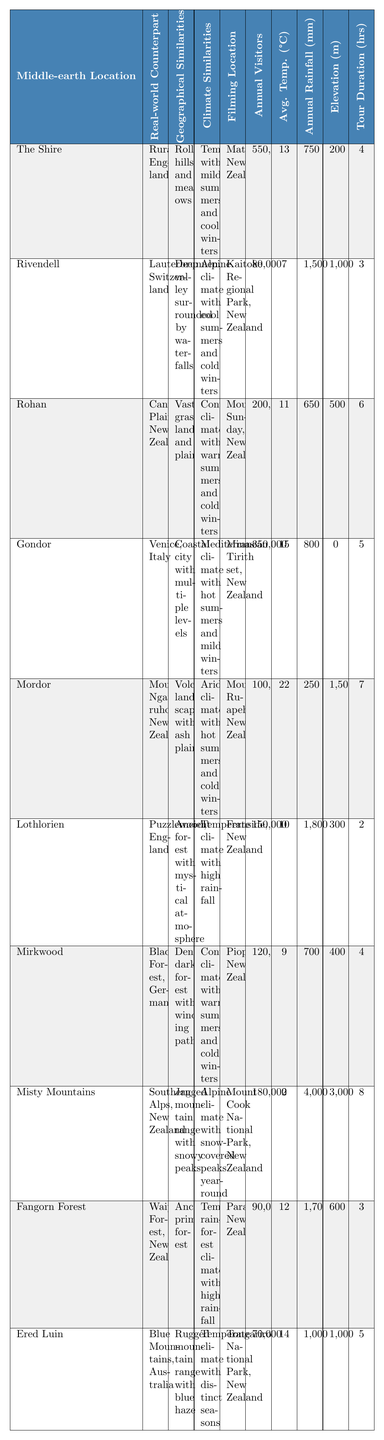What is the real-world counterpart of The Shire? Referring to the table, The Shire corresponds to Rural England.
Answer: Rural England Which Middle-earth location has the highest average temperature? By examining the average temperatures provided, Mordor has the highest average temperature at 22°C.
Answer: 22°C How many annual visitors does Rivendell have? According to the data in the table, Rivendell has 80,000 annual visitors.
Answer: 80,000 Is the climate of Gondor Mediterranean? The table indicates that Gondor has a Mediterranean climate, so the answer is yes.
Answer: Yes Which location has the lowest elevation? By comparing the elevation values, Gondor has an elevation of 0 meters, making it the lowest.
Answer: 0 meters What is the average annual rainfall of Lothlorien? Referring to the rainfall data, Lothlorien receives 1,800 mm of annual rainfall.
Answer: 1,800 mm Calculate the total annual visitors for the locations in New Zealand (The Shire, Rohan, Gondor, Mordor, Lothlorien, Mirkwood, Misty Mountains, Fangorn Forest, Ered Luin). The total is calculated as 550,000 + 200,000 + 350,000 + 100,000 + 150,000 + 120,000 + 180,000 + 90,000 + 70,000 = 1,810,000 visitors.
Answer: 1,810,000 Which location has both high rainfall and high elevation? Referring to the table, Misty Mountains has 4,000 mm of annual rainfall and an elevation of 3,000 meters.
Answer: Misty Mountains What's the average tour duration for all locations? The tour durations are 4, 3, 6, 5, 7, 2, 4, 8, 3, 5 hours, totaling 43 hours. Dividing by the number of locations (10), the average tour duration is 4.3 hours.
Answer: 4.3 hours Which Middle-earth locations have a continental climate? Looking at the climate similarities, Rohan, Mirkwood, and Mordor are associated with a continental climate.
Answer: Rohan, Mirkwood, and Mordor Is Fangorn Forest in a temperate rainforest climate? Based on the climate data in the table, Fangorn Forest has a temperate rainforest climate, so the answer is yes.
Answer: Yes 